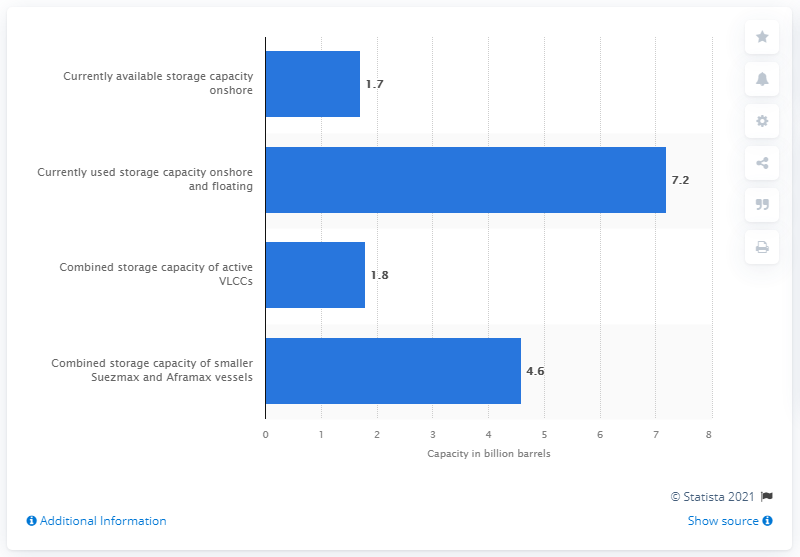Draw attention to some important aspects in this diagram. In March 2020, 1.7 barrels of onshore storage were available. There are currently 7.2 barrels of crude oil being stored onshore and on floating vessels. 